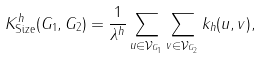Convert formula to latex. <formula><loc_0><loc_0><loc_500><loc_500>K _ { \text {Size} } ^ { h } ( G _ { 1 } , G _ { 2 } ) = \frac { 1 } { \lambda ^ { h } } \sum _ { u \in \mathcal { V } _ { G _ { 1 } } } \sum _ { v \in \mathcal { V } _ { G _ { 2 } } } k _ { h } ( u , v ) ,</formula> 